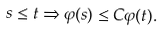<formula> <loc_0><loc_0><loc_500><loc_500>s \leq t \Rightarrow \varphi ( s ) \leq C \varphi ( t ) .</formula> 